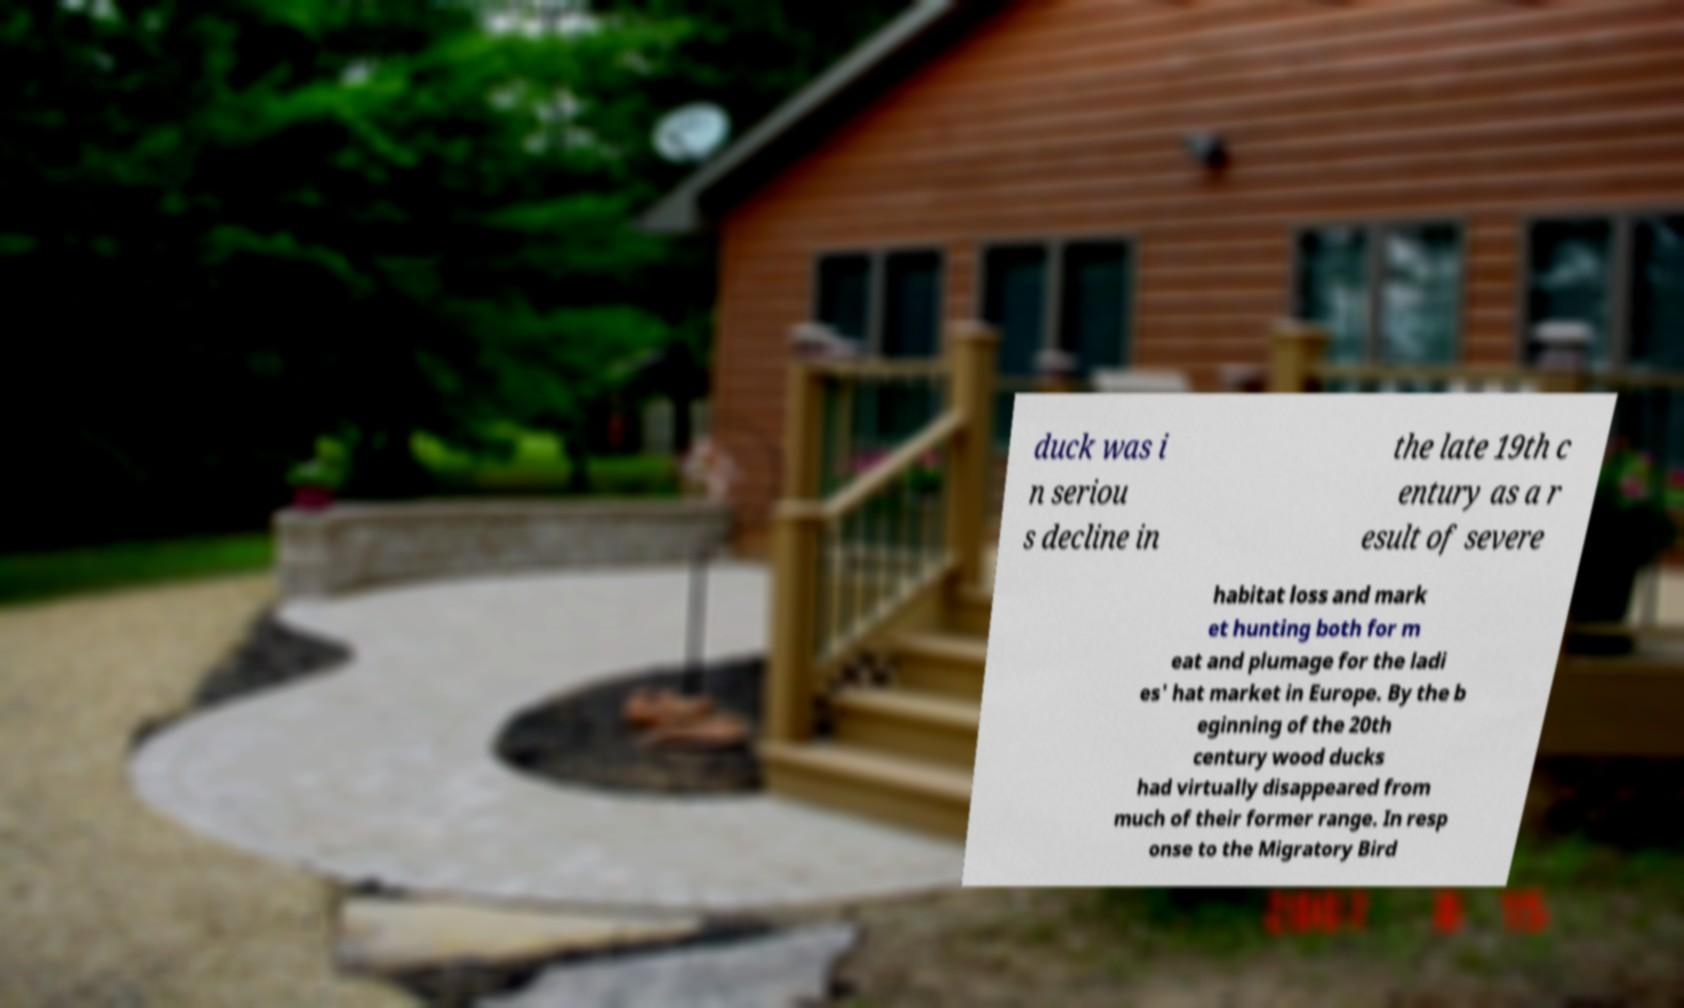Could you extract and type out the text from this image? duck was i n seriou s decline in the late 19th c entury as a r esult of severe habitat loss and mark et hunting both for m eat and plumage for the ladi es' hat market in Europe. By the b eginning of the 20th century wood ducks had virtually disappeared from much of their former range. In resp onse to the Migratory Bird 